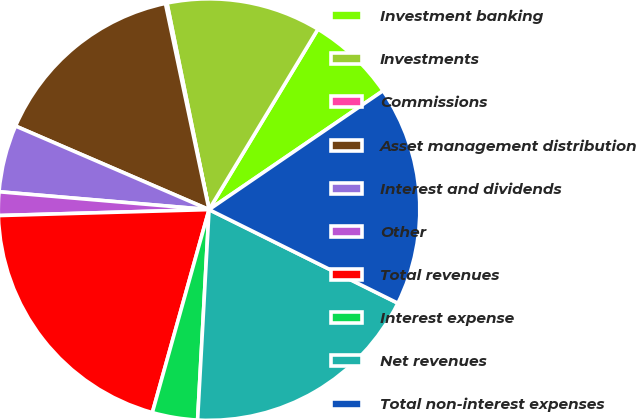Convert chart. <chart><loc_0><loc_0><loc_500><loc_500><pie_chart><fcel>Investment banking<fcel>Investments<fcel>Commissions<fcel>Asset management distribution<fcel>Interest and dividends<fcel>Other<fcel>Total revenues<fcel>Interest expense<fcel>Net revenues<fcel>Total non-interest expenses<nl><fcel>6.82%<fcel>11.84%<fcel>0.12%<fcel>15.19%<fcel>5.14%<fcel>1.8%<fcel>20.21%<fcel>3.47%<fcel>18.54%<fcel>16.86%<nl></chart> 